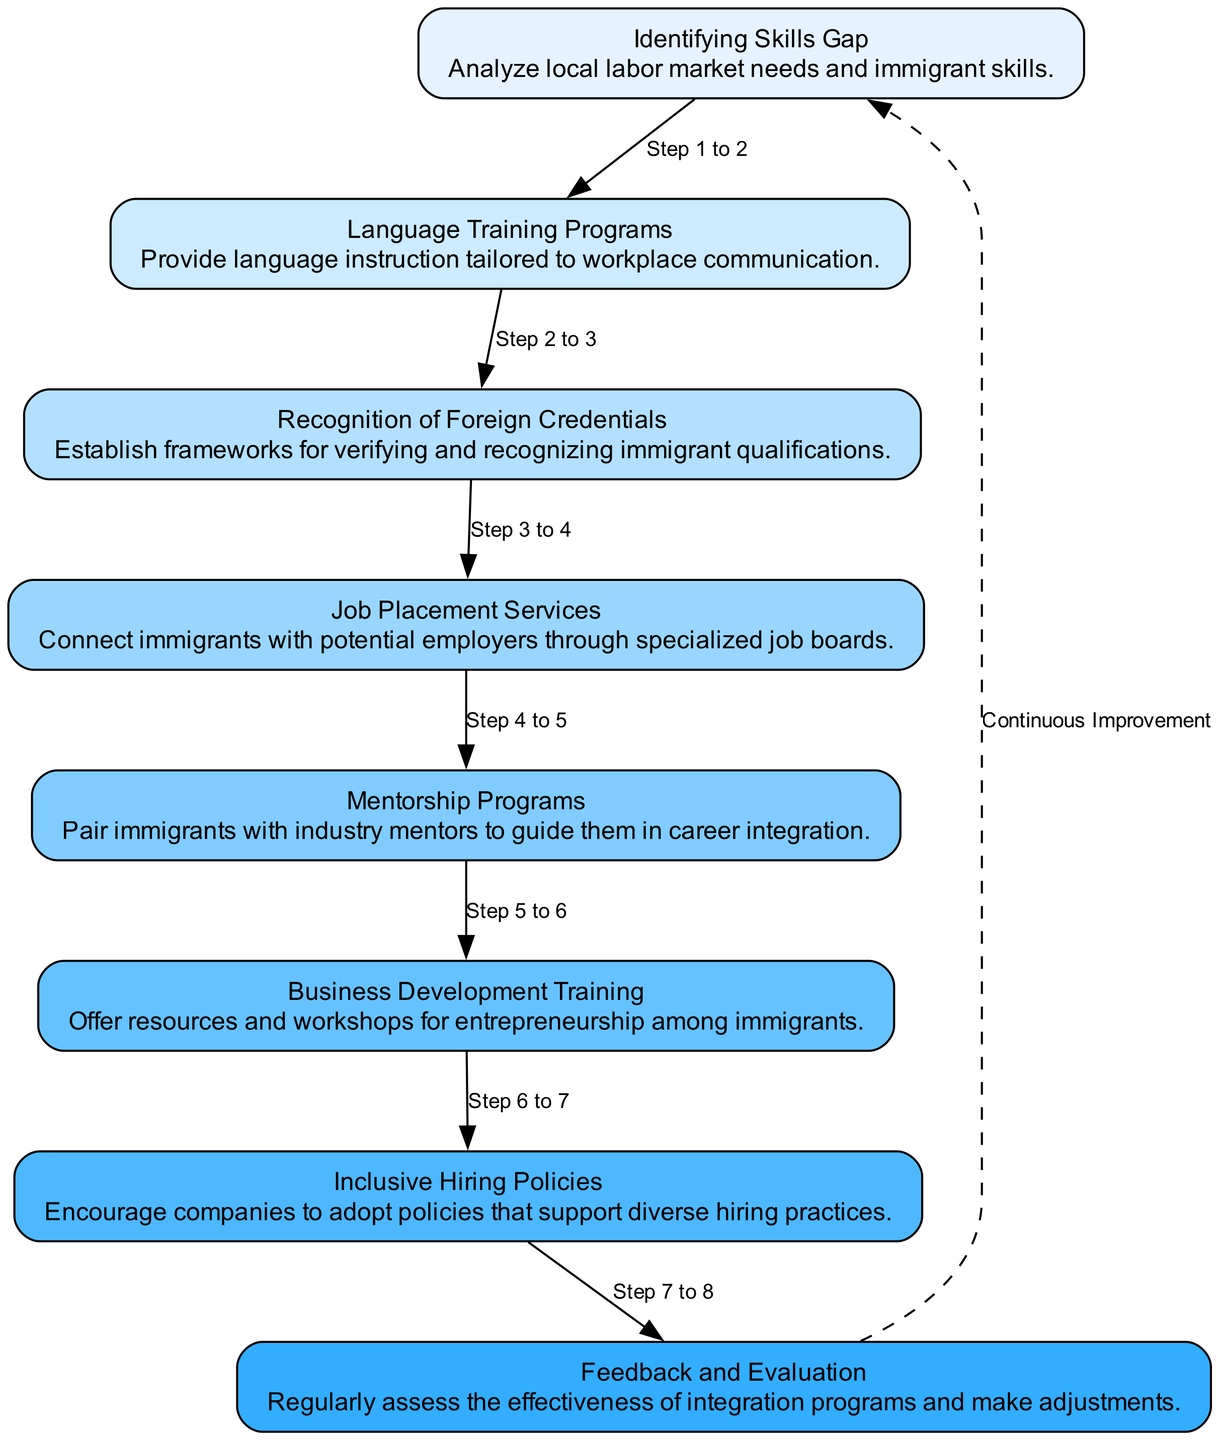What is the first step in the process? The diagram indicates that the first step is "Identifying Skills Gap". This is represented as the first node in the flow chart with the description of analyzing local labor market needs and immigrant skills.
Answer: Identifying Skills Gap How many nodes are in the diagram? The diagram contains a total of eight nodes, each representing a different step in the labor market integration process.
Answer: 8 What step is after "Language Training Programs"? Following the "Language Training Programs" node, the next step in the flow chart is "Recognition of Foreign Credentials", which is the third node in the sequence.
Answer: Recognition of Foreign Credentials How many connections (edges) are there in total? The diagram illustrates a total of seven connections (edges) between the eight distinct steps, indicating the flow from one process to the next.
Answer: 7 What node is referred to by the label in the edge from "Job Placement Services"? The edge from "Job Placement Services" leads to "Mentorship Programs", indicating that after job placement services are accessed, mentorship follows in the sequence.
Answer: Mentorship Programs Which component suggests continuous improvement? The diagram features a dashed edge labeled "Continuous Improvement" that loops back from the last node, "Feedback and Evaluation", to the first node, indicating an ongoing evaluation process for enhancements.
Answer: Continuous Improvement What is the primary focus of the "Business Development Training" step? The "Business Development Training" focuses on offering resources and workshops aimed at entrepreneurship among immigrants, as described in the node.
Answer: Entrepreneurship Which policy is highlighted to assist inclusion in hiring? The "Inclusive Hiring Policies" step emphasizes adopting policies that support diverse hiring practices, as stated in its description.
Answer: Diverse hiring practices 